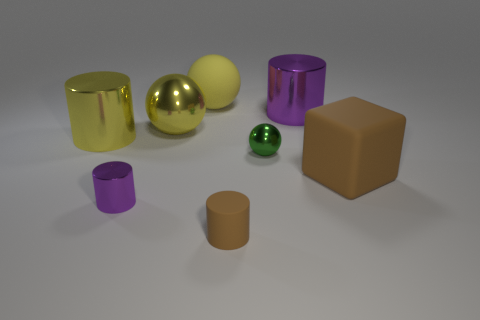There is another small shiny object that is the same shape as the small brown thing; what is its color?
Your answer should be very brief. Purple. Are there any other things that are the same shape as the big brown matte object?
Your response must be concise. No. What number of balls are rubber objects or yellow things?
Provide a succinct answer. 2. There is a small matte object; what shape is it?
Your answer should be very brief. Cylinder. There is a large yellow matte object; are there any purple metallic objects right of it?
Make the answer very short. Yes. Do the small purple object and the brown thing on the left side of the brown cube have the same material?
Offer a very short reply. No. There is a small metallic thing that is to the left of the big yellow matte ball; is it the same shape as the large purple metallic thing?
Provide a short and direct response. Yes. How many large cylinders have the same material as the small green ball?
Your answer should be compact. 2. How many things are purple metallic objects that are left of the green metallic object or purple rubber cubes?
Keep it short and to the point. 1. What size is the green sphere?
Provide a succinct answer. Small. 